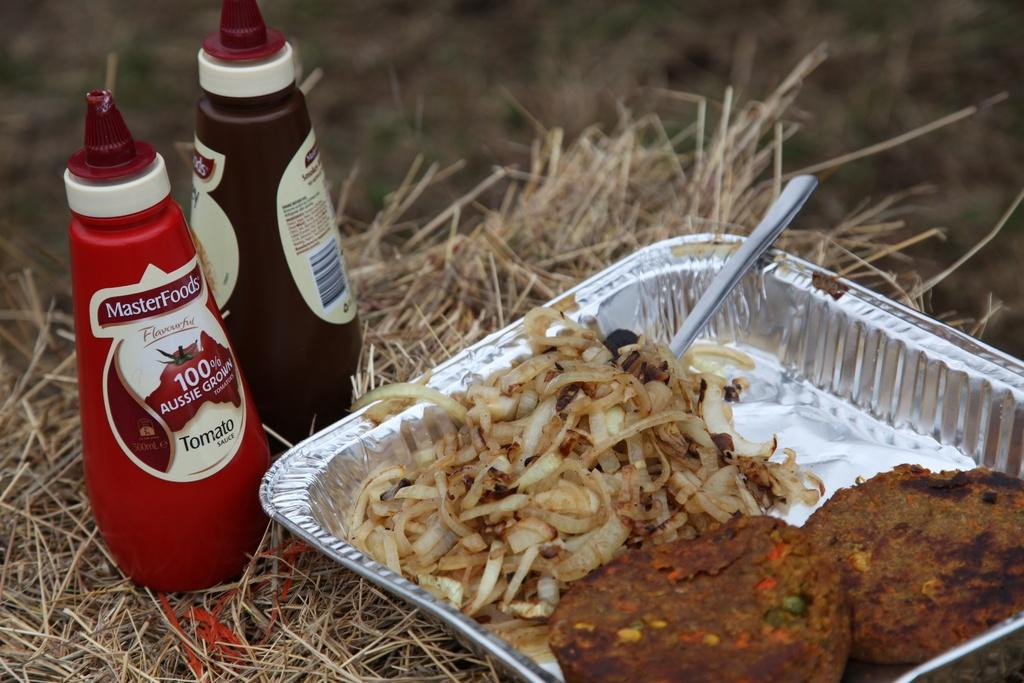<image>
Share a concise interpretation of the image provided. Foil pan with two burgers and onions with bottle of MasterFoods 100% Aussie grown tomato sauce 